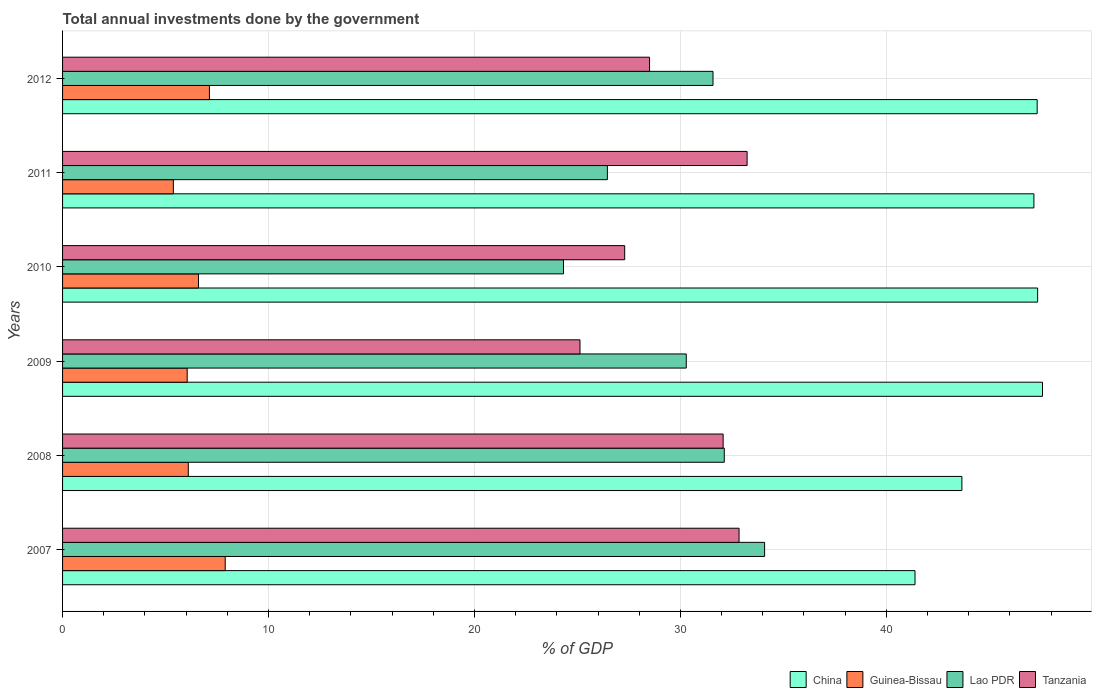How many groups of bars are there?
Provide a short and direct response. 6. Are the number of bars per tick equal to the number of legend labels?
Your answer should be compact. Yes. Are the number of bars on each tick of the Y-axis equal?
Your answer should be compact. Yes. What is the label of the 4th group of bars from the top?
Your answer should be very brief. 2009. What is the total annual investments done by the government in Lao PDR in 2009?
Give a very brief answer. 30.29. Across all years, what is the maximum total annual investments done by the government in Lao PDR?
Provide a short and direct response. 34.09. Across all years, what is the minimum total annual investments done by the government in Lao PDR?
Ensure brevity in your answer.  24.32. In which year was the total annual investments done by the government in Tanzania maximum?
Your answer should be very brief. 2011. In which year was the total annual investments done by the government in Guinea-Bissau minimum?
Provide a succinct answer. 2011. What is the total total annual investments done by the government in China in the graph?
Give a very brief answer. 274.49. What is the difference between the total annual investments done by the government in Guinea-Bissau in 2007 and that in 2010?
Give a very brief answer. 1.3. What is the difference between the total annual investments done by the government in Tanzania in 2011 and the total annual investments done by the government in China in 2012?
Your response must be concise. -14.08. What is the average total annual investments done by the government in Lao PDR per year?
Give a very brief answer. 29.81. In the year 2011, what is the difference between the total annual investments done by the government in Tanzania and total annual investments done by the government in Lao PDR?
Your answer should be compact. 6.78. In how many years, is the total annual investments done by the government in China greater than 42 %?
Your response must be concise. 5. What is the ratio of the total annual investments done by the government in China in 2011 to that in 2012?
Your response must be concise. 1. Is the difference between the total annual investments done by the government in Tanzania in 2008 and 2011 greater than the difference between the total annual investments done by the government in Lao PDR in 2008 and 2011?
Offer a terse response. No. What is the difference between the highest and the second highest total annual investments done by the government in Lao PDR?
Your response must be concise. 1.96. What is the difference between the highest and the lowest total annual investments done by the government in Tanzania?
Offer a terse response. 8.12. What does the 3rd bar from the top in 2011 represents?
Give a very brief answer. Guinea-Bissau. What does the 2nd bar from the bottom in 2011 represents?
Provide a succinct answer. Guinea-Bissau. Is it the case that in every year, the sum of the total annual investments done by the government in Guinea-Bissau and total annual investments done by the government in Lao PDR is greater than the total annual investments done by the government in Tanzania?
Your answer should be very brief. No. How many years are there in the graph?
Your answer should be compact. 6. What is the difference between two consecutive major ticks on the X-axis?
Make the answer very short. 10. Are the values on the major ticks of X-axis written in scientific E-notation?
Ensure brevity in your answer.  No. Does the graph contain any zero values?
Provide a short and direct response. No. How many legend labels are there?
Your answer should be compact. 4. How are the legend labels stacked?
Your answer should be compact. Horizontal. What is the title of the graph?
Offer a very short reply. Total annual investments done by the government. What is the label or title of the X-axis?
Your response must be concise. % of GDP. What is the label or title of the Y-axis?
Your response must be concise. Years. What is the % of GDP in China in 2007?
Ensure brevity in your answer.  41.39. What is the % of GDP in Guinea-Bissau in 2007?
Offer a very short reply. 7.9. What is the % of GDP of Lao PDR in 2007?
Offer a terse response. 34.09. What is the % of GDP in Tanzania in 2007?
Provide a succinct answer. 32.85. What is the % of GDP in China in 2008?
Give a very brief answer. 43.67. What is the % of GDP in Guinea-Bissau in 2008?
Give a very brief answer. 6.11. What is the % of GDP in Lao PDR in 2008?
Your response must be concise. 32.13. What is the % of GDP of Tanzania in 2008?
Provide a short and direct response. 32.08. What is the % of GDP in China in 2009?
Provide a short and direct response. 47.58. What is the % of GDP in Guinea-Bissau in 2009?
Make the answer very short. 6.05. What is the % of GDP in Lao PDR in 2009?
Provide a succinct answer. 30.29. What is the % of GDP in Tanzania in 2009?
Make the answer very short. 25.13. What is the % of GDP in China in 2010?
Provide a short and direct response. 47.35. What is the % of GDP of Guinea-Bissau in 2010?
Offer a terse response. 6.6. What is the % of GDP in Lao PDR in 2010?
Offer a terse response. 24.32. What is the % of GDP in Tanzania in 2010?
Your answer should be very brief. 27.3. What is the % of GDP in China in 2011?
Give a very brief answer. 47.17. What is the % of GDP of Guinea-Bissau in 2011?
Provide a short and direct response. 5.38. What is the % of GDP in Lao PDR in 2011?
Make the answer very short. 26.46. What is the % of GDP in Tanzania in 2011?
Give a very brief answer. 33.24. What is the % of GDP of China in 2012?
Offer a very short reply. 47.32. What is the % of GDP of Guinea-Bissau in 2012?
Give a very brief answer. 7.13. What is the % of GDP in Lao PDR in 2012?
Offer a terse response. 31.58. What is the % of GDP of Tanzania in 2012?
Your response must be concise. 28.5. Across all years, what is the maximum % of GDP of China?
Provide a succinct answer. 47.58. Across all years, what is the maximum % of GDP in Guinea-Bissau?
Your answer should be compact. 7.9. Across all years, what is the maximum % of GDP of Lao PDR?
Ensure brevity in your answer.  34.09. Across all years, what is the maximum % of GDP in Tanzania?
Make the answer very short. 33.24. Across all years, what is the minimum % of GDP of China?
Ensure brevity in your answer.  41.39. Across all years, what is the minimum % of GDP of Guinea-Bissau?
Offer a very short reply. 5.38. Across all years, what is the minimum % of GDP in Lao PDR?
Offer a terse response. 24.32. Across all years, what is the minimum % of GDP of Tanzania?
Your response must be concise. 25.13. What is the total % of GDP of China in the graph?
Offer a terse response. 274.49. What is the total % of GDP in Guinea-Bissau in the graph?
Offer a very short reply. 39.17. What is the total % of GDP in Lao PDR in the graph?
Your response must be concise. 178.87. What is the total % of GDP in Tanzania in the graph?
Your response must be concise. 179.09. What is the difference between the % of GDP of China in 2007 and that in 2008?
Provide a short and direct response. -2.28. What is the difference between the % of GDP in Guinea-Bissau in 2007 and that in 2008?
Your answer should be compact. 1.79. What is the difference between the % of GDP in Lao PDR in 2007 and that in 2008?
Provide a succinct answer. 1.96. What is the difference between the % of GDP in Tanzania in 2007 and that in 2008?
Make the answer very short. 0.77. What is the difference between the % of GDP in China in 2007 and that in 2009?
Make the answer very short. -6.19. What is the difference between the % of GDP in Guinea-Bissau in 2007 and that in 2009?
Ensure brevity in your answer.  1.85. What is the difference between the % of GDP in Lao PDR in 2007 and that in 2009?
Provide a short and direct response. 3.8. What is the difference between the % of GDP in Tanzania in 2007 and that in 2009?
Provide a short and direct response. 7.72. What is the difference between the % of GDP of China in 2007 and that in 2010?
Keep it short and to the point. -5.95. What is the difference between the % of GDP in Guinea-Bissau in 2007 and that in 2010?
Give a very brief answer. 1.3. What is the difference between the % of GDP of Lao PDR in 2007 and that in 2010?
Make the answer very short. 9.77. What is the difference between the % of GDP in Tanzania in 2007 and that in 2010?
Offer a very short reply. 5.55. What is the difference between the % of GDP in China in 2007 and that in 2011?
Ensure brevity in your answer.  -5.77. What is the difference between the % of GDP of Guinea-Bissau in 2007 and that in 2011?
Offer a very short reply. 2.52. What is the difference between the % of GDP of Lao PDR in 2007 and that in 2011?
Ensure brevity in your answer.  7.63. What is the difference between the % of GDP of Tanzania in 2007 and that in 2011?
Provide a short and direct response. -0.39. What is the difference between the % of GDP in China in 2007 and that in 2012?
Your response must be concise. -5.93. What is the difference between the % of GDP in Guinea-Bissau in 2007 and that in 2012?
Offer a very short reply. 0.77. What is the difference between the % of GDP in Lao PDR in 2007 and that in 2012?
Your answer should be compact. 2.5. What is the difference between the % of GDP of Tanzania in 2007 and that in 2012?
Make the answer very short. 4.35. What is the difference between the % of GDP in China in 2008 and that in 2009?
Provide a short and direct response. -3.91. What is the difference between the % of GDP in Guinea-Bissau in 2008 and that in 2009?
Provide a short and direct response. 0.05. What is the difference between the % of GDP of Lao PDR in 2008 and that in 2009?
Make the answer very short. 1.85. What is the difference between the % of GDP in Tanzania in 2008 and that in 2009?
Your answer should be compact. 6.95. What is the difference between the % of GDP of China in 2008 and that in 2010?
Keep it short and to the point. -3.68. What is the difference between the % of GDP in Guinea-Bissau in 2008 and that in 2010?
Make the answer very short. -0.49. What is the difference between the % of GDP in Lao PDR in 2008 and that in 2010?
Offer a terse response. 7.81. What is the difference between the % of GDP of Tanzania in 2008 and that in 2010?
Your response must be concise. 4.78. What is the difference between the % of GDP of China in 2008 and that in 2011?
Provide a succinct answer. -3.5. What is the difference between the % of GDP of Guinea-Bissau in 2008 and that in 2011?
Offer a very short reply. 0.73. What is the difference between the % of GDP of Lao PDR in 2008 and that in 2011?
Ensure brevity in your answer.  5.68. What is the difference between the % of GDP in Tanzania in 2008 and that in 2011?
Your answer should be compact. -1.16. What is the difference between the % of GDP of China in 2008 and that in 2012?
Offer a terse response. -3.65. What is the difference between the % of GDP of Guinea-Bissau in 2008 and that in 2012?
Provide a succinct answer. -1.02. What is the difference between the % of GDP in Lao PDR in 2008 and that in 2012?
Make the answer very short. 0.55. What is the difference between the % of GDP in Tanzania in 2008 and that in 2012?
Offer a terse response. 3.57. What is the difference between the % of GDP in China in 2009 and that in 2010?
Your answer should be compact. 0.24. What is the difference between the % of GDP in Guinea-Bissau in 2009 and that in 2010?
Offer a terse response. -0.55. What is the difference between the % of GDP of Lao PDR in 2009 and that in 2010?
Provide a succinct answer. 5.96. What is the difference between the % of GDP of Tanzania in 2009 and that in 2010?
Offer a terse response. -2.17. What is the difference between the % of GDP in China in 2009 and that in 2011?
Your response must be concise. 0.42. What is the difference between the % of GDP of Guinea-Bissau in 2009 and that in 2011?
Make the answer very short. 0.67. What is the difference between the % of GDP in Lao PDR in 2009 and that in 2011?
Offer a very short reply. 3.83. What is the difference between the % of GDP of Tanzania in 2009 and that in 2011?
Provide a short and direct response. -8.12. What is the difference between the % of GDP in China in 2009 and that in 2012?
Make the answer very short. 0.26. What is the difference between the % of GDP in Guinea-Bissau in 2009 and that in 2012?
Ensure brevity in your answer.  -1.08. What is the difference between the % of GDP in Lao PDR in 2009 and that in 2012?
Your answer should be very brief. -1.3. What is the difference between the % of GDP in Tanzania in 2009 and that in 2012?
Make the answer very short. -3.38. What is the difference between the % of GDP of China in 2010 and that in 2011?
Ensure brevity in your answer.  0.18. What is the difference between the % of GDP in Guinea-Bissau in 2010 and that in 2011?
Provide a short and direct response. 1.22. What is the difference between the % of GDP of Lao PDR in 2010 and that in 2011?
Your response must be concise. -2.13. What is the difference between the % of GDP of Tanzania in 2010 and that in 2011?
Provide a short and direct response. -5.94. What is the difference between the % of GDP of China in 2010 and that in 2012?
Your response must be concise. 0.02. What is the difference between the % of GDP of Guinea-Bissau in 2010 and that in 2012?
Ensure brevity in your answer.  -0.53. What is the difference between the % of GDP of Lao PDR in 2010 and that in 2012?
Provide a short and direct response. -7.26. What is the difference between the % of GDP of Tanzania in 2010 and that in 2012?
Your response must be concise. -1.21. What is the difference between the % of GDP in China in 2011 and that in 2012?
Your response must be concise. -0.16. What is the difference between the % of GDP in Guinea-Bissau in 2011 and that in 2012?
Give a very brief answer. -1.75. What is the difference between the % of GDP in Lao PDR in 2011 and that in 2012?
Provide a succinct answer. -5.13. What is the difference between the % of GDP in Tanzania in 2011 and that in 2012?
Offer a terse response. 4.74. What is the difference between the % of GDP in China in 2007 and the % of GDP in Guinea-Bissau in 2008?
Make the answer very short. 35.29. What is the difference between the % of GDP in China in 2007 and the % of GDP in Lao PDR in 2008?
Keep it short and to the point. 9.26. What is the difference between the % of GDP of China in 2007 and the % of GDP of Tanzania in 2008?
Give a very brief answer. 9.32. What is the difference between the % of GDP in Guinea-Bissau in 2007 and the % of GDP in Lao PDR in 2008?
Ensure brevity in your answer.  -24.23. What is the difference between the % of GDP in Guinea-Bissau in 2007 and the % of GDP in Tanzania in 2008?
Ensure brevity in your answer.  -24.18. What is the difference between the % of GDP in Lao PDR in 2007 and the % of GDP in Tanzania in 2008?
Your answer should be compact. 2.01. What is the difference between the % of GDP of China in 2007 and the % of GDP of Guinea-Bissau in 2009?
Ensure brevity in your answer.  35.34. What is the difference between the % of GDP of China in 2007 and the % of GDP of Lao PDR in 2009?
Provide a succinct answer. 11.11. What is the difference between the % of GDP in China in 2007 and the % of GDP in Tanzania in 2009?
Ensure brevity in your answer.  16.27. What is the difference between the % of GDP of Guinea-Bissau in 2007 and the % of GDP of Lao PDR in 2009?
Ensure brevity in your answer.  -22.39. What is the difference between the % of GDP of Guinea-Bissau in 2007 and the % of GDP of Tanzania in 2009?
Provide a short and direct response. -17.23. What is the difference between the % of GDP in Lao PDR in 2007 and the % of GDP in Tanzania in 2009?
Give a very brief answer. 8.96. What is the difference between the % of GDP in China in 2007 and the % of GDP in Guinea-Bissau in 2010?
Give a very brief answer. 34.79. What is the difference between the % of GDP in China in 2007 and the % of GDP in Lao PDR in 2010?
Keep it short and to the point. 17.07. What is the difference between the % of GDP in China in 2007 and the % of GDP in Tanzania in 2010?
Your answer should be compact. 14.1. What is the difference between the % of GDP of Guinea-Bissau in 2007 and the % of GDP of Lao PDR in 2010?
Your answer should be very brief. -16.43. What is the difference between the % of GDP of Guinea-Bissau in 2007 and the % of GDP of Tanzania in 2010?
Give a very brief answer. -19.4. What is the difference between the % of GDP of Lao PDR in 2007 and the % of GDP of Tanzania in 2010?
Give a very brief answer. 6.79. What is the difference between the % of GDP in China in 2007 and the % of GDP in Guinea-Bissau in 2011?
Your answer should be very brief. 36.01. What is the difference between the % of GDP in China in 2007 and the % of GDP in Lao PDR in 2011?
Your answer should be compact. 14.94. What is the difference between the % of GDP in China in 2007 and the % of GDP in Tanzania in 2011?
Your answer should be compact. 8.15. What is the difference between the % of GDP in Guinea-Bissau in 2007 and the % of GDP in Lao PDR in 2011?
Ensure brevity in your answer.  -18.56. What is the difference between the % of GDP in Guinea-Bissau in 2007 and the % of GDP in Tanzania in 2011?
Provide a succinct answer. -25.34. What is the difference between the % of GDP of Lao PDR in 2007 and the % of GDP of Tanzania in 2011?
Offer a very short reply. 0.85. What is the difference between the % of GDP in China in 2007 and the % of GDP in Guinea-Bissau in 2012?
Provide a short and direct response. 34.26. What is the difference between the % of GDP of China in 2007 and the % of GDP of Lao PDR in 2012?
Your answer should be compact. 9.81. What is the difference between the % of GDP in China in 2007 and the % of GDP in Tanzania in 2012?
Offer a very short reply. 12.89. What is the difference between the % of GDP in Guinea-Bissau in 2007 and the % of GDP in Lao PDR in 2012?
Keep it short and to the point. -23.69. What is the difference between the % of GDP in Guinea-Bissau in 2007 and the % of GDP in Tanzania in 2012?
Ensure brevity in your answer.  -20.6. What is the difference between the % of GDP in Lao PDR in 2007 and the % of GDP in Tanzania in 2012?
Provide a succinct answer. 5.59. What is the difference between the % of GDP in China in 2008 and the % of GDP in Guinea-Bissau in 2009?
Your answer should be compact. 37.62. What is the difference between the % of GDP of China in 2008 and the % of GDP of Lao PDR in 2009?
Make the answer very short. 13.38. What is the difference between the % of GDP of China in 2008 and the % of GDP of Tanzania in 2009?
Keep it short and to the point. 18.54. What is the difference between the % of GDP of Guinea-Bissau in 2008 and the % of GDP of Lao PDR in 2009?
Your answer should be very brief. -24.18. What is the difference between the % of GDP of Guinea-Bissau in 2008 and the % of GDP of Tanzania in 2009?
Your answer should be compact. -19.02. What is the difference between the % of GDP in Lao PDR in 2008 and the % of GDP in Tanzania in 2009?
Make the answer very short. 7.01. What is the difference between the % of GDP of China in 2008 and the % of GDP of Guinea-Bissau in 2010?
Make the answer very short. 37.07. What is the difference between the % of GDP of China in 2008 and the % of GDP of Lao PDR in 2010?
Give a very brief answer. 19.35. What is the difference between the % of GDP of China in 2008 and the % of GDP of Tanzania in 2010?
Offer a terse response. 16.37. What is the difference between the % of GDP of Guinea-Bissau in 2008 and the % of GDP of Lao PDR in 2010?
Provide a succinct answer. -18.22. What is the difference between the % of GDP in Guinea-Bissau in 2008 and the % of GDP in Tanzania in 2010?
Give a very brief answer. -21.19. What is the difference between the % of GDP of Lao PDR in 2008 and the % of GDP of Tanzania in 2010?
Your answer should be compact. 4.84. What is the difference between the % of GDP of China in 2008 and the % of GDP of Guinea-Bissau in 2011?
Give a very brief answer. 38.29. What is the difference between the % of GDP in China in 2008 and the % of GDP in Lao PDR in 2011?
Your response must be concise. 17.21. What is the difference between the % of GDP of China in 2008 and the % of GDP of Tanzania in 2011?
Your answer should be compact. 10.43. What is the difference between the % of GDP in Guinea-Bissau in 2008 and the % of GDP in Lao PDR in 2011?
Your answer should be very brief. -20.35. What is the difference between the % of GDP in Guinea-Bissau in 2008 and the % of GDP in Tanzania in 2011?
Provide a succinct answer. -27.13. What is the difference between the % of GDP of Lao PDR in 2008 and the % of GDP of Tanzania in 2011?
Your response must be concise. -1.11. What is the difference between the % of GDP of China in 2008 and the % of GDP of Guinea-Bissau in 2012?
Provide a short and direct response. 36.54. What is the difference between the % of GDP of China in 2008 and the % of GDP of Lao PDR in 2012?
Your answer should be very brief. 12.09. What is the difference between the % of GDP in China in 2008 and the % of GDP in Tanzania in 2012?
Your response must be concise. 15.17. What is the difference between the % of GDP of Guinea-Bissau in 2008 and the % of GDP of Lao PDR in 2012?
Make the answer very short. -25.48. What is the difference between the % of GDP in Guinea-Bissau in 2008 and the % of GDP in Tanzania in 2012?
Your answer should be very brief. -22.4. What is the difference between the % of GDP of Lao PDR in 2008 and the % of GDP of Tanzania in 2012?
Provide a succinct answer. 3.63. What is the difference between the % of GDP in China in 2009 and the % of GDP in Guinea-Bissau in 2010?
Offer a terse response. 40.98. What is the difference between the % of GDP in China in 2009 and the % of GDP in Lao PDR in 2010?
Your response must be concise. 23.26. What is the difference between the % of GDP in China in 2009 and the % of GDP in Tanzania in 2010?
Offer a terse response. 20.29. What is the difference between the % of GDP in Guinea-Bissau in 2009 and the % of GDP in Lao PDR in 2010?
Provide a short and direct response. -18.27. What is the difference between the % of GDP in Guinea-Bissau in 2009 and the % of GDP in Tanzania in 2010?
Offer a terse response. -21.24. What is the difference between the % of GDP in Lao PDR in 2009 and the % of GDP in Tanzania in 2010?
Your answer should be very brief. 2.99. What is the difference between the % of GDP of China in 2009 and the % of GDP of Guinea-Bissau in 2011?
Provide a short and direct response. 42.2. What is the difference between the % of GDP in China in 2009 and the % of GDP in Lao PDR in 2011?
Offer a very short reply. 21.13. What is the difference between the % of GDP in China in 2009 and the % of GDP in Tanzania in 2011?
Give a very brief answer. 14.34. What is the difference between the % of GDP of Guinea-Bissau in 2009 and the % of GDP of Lao PDR in 2011?
Offer a very short reply. -20.4. What is the difference between the % of GDP in Guinea-Bissau in 2009 and the % of GDP in Tanzania in 2011?
Keep it short and to the point. -27.19. What is the difference between the % of GDP of Lao PDR in 2009 and the % of GDP of Tanzania in 2011?
Keep it short and to the point. -2.95. What is the difference between the % of GDP of China in 2009 and the % of GDP of Guinea-Bissau in 2012?
Give a very brief answer. 40.45. What is the difference between the % of GDP in China in 2009 and the % of GDP in Lao PDR in 2012?
Offer a terse response. 16. What is the difference between the % of GDP in China in 2009 and the % of GDP in Tanzania in 2012?
Provide a succinct answer. 19.08. What is the difference between the % of GDP in Guinea-Bissau in 2009 and the % of GDP in Lao PDR in 2012?
Offer a terse response. -25.53. What is the difference between the % of GDP of Guinea-Bissau in 2009 and the % of GDP of Tanzania in 2012?
Provide a succinct answer. -22.45. What is the difference between the % of GDP in Lao PDR in 2009 and the % of GDP in Tanzania in 2012?
Give a very brief answer. 1.78. What is the difference between the % of GDP of China in 2010 and the % of GDP of Guinea-Bissau in 2011?
Offer a terse response. 41.97. What is the difference between the % of GDP of China in 2010 and the % of GDP of Lao PDR in 2011?
Your answer should be compact. 20.89. What is the difference between the % of GDP in China in 2010 and the % of GDP in Tanzania in 2011?
Offer a very short reply. 14.11. What is the difference between the % of GDP of Guinea-Bissau in 2010 and the % of GDP of Lao PDR in 2011?
Offer a terse response. -19.86. What is the difference between the % of GDP in Guinea-Bissau in 2010 and the % of GDP in Tanzania in 2011?
Your answer should be very brief. -26.64. What is the difference between the % of GDP in Lao PDR in 2010 and the % of GDP in Tanzania in 2011?
Ensure brevity in your answer.  -8.92. What is the difference between the % of GDP of China in 2010 and the % of GDP of Guinea-Bissau in 2012?
Your answer should be very brief. 40.22. What is the difference between the % of GDP of China in 2010 and the % of GDP of Lao PDR in 2012?
Ensure brevity in your answer.  15.76. What is the difference between the % of GDP in China in 2010 and the % of GDP in Tanzania in 2012?
Offer a terse response. 18.84. What is the difference between the % of GDP of Guinea-Bissau in 2010 and the % of GDP of Lao PDR in 2012?
Your answer should be compact. -24.98. What is the difference between the % of GDP in Guinea-Bissau in 2010 and the % of GDP in Tanzania in 2012?
Your answer should be compact. -21.9. What is the difference between the % of GDP in Lao PDR in 2010 and the % of GDP in Tanzania in 2012?
Keep it short and to the point. -4.18. What is the difference between the % of GDP of China in 2011 and the % of GDP of Guinea-Bissau in 2012?
Keep it short and to the point. 40.04. What is the difference between the % of GDP of China in 2011 and the % of GDP of Lao PDR in 2012?
Give a very brief answer. 15.58. What is the difference between the % of GDP in China in 2011 and the % of GDP in Tanzania in 2012?
Provide a short and direct response. 18.66. What is the difference between the % of GDP in Guinea-Bissau in 2011 and the % of GDP in Lao PDR in 2012?
Ensure brevity in your answer.  -26.21. What is the difference between the % of GDP in Guinea-Bissau in 2011 and the % of GDP in Tanzania in 2012?
Your answer should be very brief. -23.12. What is the difference between the % of GDP of Lao PDR in 2011 and the % of GDP of Tanzania in 2012?
Give a very brief answer. -2.05. What is the average % of GDP of China per year?
Provide a succinct answer. 45.75. What is the average % of GDP in Guinea-Bissau per year?
Your response must be concise. 6.53. What is the average % of GDP of Lao PDR per year?
Your answer should be compact. 29.81. What is the average % of GDP of Tanzania per year?
Make the answer very short. 29.85. In the year 2007, what is the difference between the % of GDP of China and % of GDP of Guinea-Bissau?
Your answer should be compact. 33.5. In the year 2007, what is the difference between the % of GDP in China and % of GDP in Lao PDR?
Offer a very short reply. 7.3. In the year 2007, what is the difference between the % of GDP in China and % of GDP in Tanzania?
Provide a succinct answer. 8.54. In the year 2007, what is the difference between the % of GDP of Guinea-Bissau and % of GDP of Lao PDR?
Your response must be concise. -26.19. In the year 2007, what is the difference between the % of GDP in Guinea-Bissau and % of GDP in Tanzania?
Provide a succinct answer. -24.95. In the year 2007, what is the difference between the % of GDP of Lao PDR and % of GDP of Tanzania?
Offer a very short reply. 1.24. In the year 2008, what is the difference between the % of GDP in China and % of GDP in Guinea-Bissau?
Your answer should be very brief. 37.56. In the year 2008, what is the difference between the % of GDP of China and % of GDP of Lao PDR?
Make the answer very short. 11.54. In the year 2008, what is the difference between the % of GDP in China and % of GDP in Tanzania?
Provide a succinct answer. 11.59. In the year 2008, what is the difference between the % of GDP of Guinea-Bissau and % of GDP of Lao PDR?
Your answer should be very brief. -26.03. In the year 2008, what is the difference between the % of GDP in Guinea-Bissau and % of GDP in Tanzania?
Keep it short and to the point. -25.97. In the year 2008, what is the difference between the % of GDP of Lao PDR and % of GDP of Tanzania?
Keep it short and to the point. 0.06. In the year 2009, what is the difference between the % of GDP in China and % of GDP in Guinea-Bissau?
Make the answer very short. 41.53. In the year 2009, what is the difference between the % of GDP in China and % of GDP in Lao PDR?
Your answer should be very brief. 17.3. In the year 2009, what is the difference between the % of GDP of China and % of GDP of Tanzania?
Your answer should be compact. 22.46. In the year 2009, what is the difference between the % of GDP in Guinea-Bissau and % of GDP in Lao PDR?
Provide a succinct answer. -24.23. In the year 2009, what is the difference between the % of GDP of Guinea-Bissau and % of GDP of Tanzania?
Your answer should be compact. -19.07. In the year 2009, what is the difference between the % of GDP of Lao PDR and % of GDP of Tanzania?
Provide a short and direct response. 5.16. In the year 2010, what is the difference between the % of GDP of China and % of GDP of Guinea-Bissau?
Give a very brief answer. 40.75. In the year 2010, what is the difference between the % of GDP in China and % of GDP in Lao PDR?
Your response must be concise. 23.02. In the year 2010, what is the difference between the % of GDP in China and % of GDP in Tanzania?
Ensure brevity in your answer.  20.05. In the year 2010, what is the difference between the % of GDP in Guinea-Bissau and % of GDP in Lao PDR?
Offer a terse response. -17.72. In the year 2010, what is the difference between the % of GDP in Guinea-Bissau and % of GDP in Tanzania?
Provide a short and direct response. -20.7. In the year 2010, what is the difference between the % of GDP in Lao PDR and % of GDP in Tanzania?
Give a very brief answer. -2.97. In the year 2011, what is the difference between the % of GDP in China and % of GDP in Guinea-Bissau?
Offer a terse response. 41.79. In the year 2011, what is the difference between the % of GDP of China and % of GDP of Lao PDR?
Your response must be concise. 20.71. In the year 2011, what is the difference between the % of GDP in China and % of GDP in Tanzania?
Keep it short and to the point. 13.93. In the year 2011, what is the difference between the % of GDP in Guinea-Bissau and % of GDP in Lao PDR?
Your answer should be very brief. -21.08. In the year 2011, what is the difference between the % of GDP in Guinea-Bissau and % of GDP in Tanzania?
Provide a succinct answer. -27.86. In the year 2011, what is the difference between the % of GDP in Lao PDR and % of GDP in Tanzania?
Offer a very short reply. -6.78. In the year 2012, what is the difference between the % of GDP of China and % of GDP of Guinea-Bissau?
Give a very brief answer. 40.19. In the year 2012, what is the difference between the % of GDP of China and % of GDP of Lao PDR?
Your response must be concise. 15.74. In the year 2012, what is the difference between the % of GDP of China and % of GDP of Tanzania?
Make the answer very short. 18.82. In the year 2012, what is the difference between the % of GDP of Guinea-Bissau and % of GDP of Lao PDR?
Your answer should be very brief. -24.45. In the year 2012, what is the difference between the % of GDP in Guinea-Bissau and % of GDP in Tanzania?
Offer a very short reply. -21.37. In the year 2012, what is the difference between the % of GDP in Lao PDR and % of GDP in Tanzania?
Your answer should be compact. 3.08. What is the ratio of the % of GDP of China in 2007 to that in 2008?
Make the answer very short. 0.95. What is the ratio of the % of GDP of Guinea-Bissau in 2007 to that in 2008?
Your answer should be very brief. 1.29. What is the ratio of the % of GDP of Lao PDR in 2007 to that in 2008?
Give a very brief answer. 1.06. What is the ratio of the % of GDP of Tanzania in 2007 to that in 2008?
Your answer should be very brief. 1.02. What is the ratio of the % of GDP of China in 2007 to that in 2009?
Your response must be concise. 0.87. What is the ratio of the % of GDP in Guinea-Bissau in 2007 to that in 2009?
Your answer should be compact. 1.31. What is the ratio of the % of GDP in Lao PDR in 2007 to that in 2009?
Offer a terse response. 1.13. What is the ratio of the % of GDP of Tanzania in 2007 to that in 2009?
Give a very brief answer. 1.31. What is the ratio of the % of GDP in China in 2007 to that in 2010?
Your answer should be very brief. 0.87. What is the ratio of the % of GDP in Guinea-Bissau in 2007 to that in 2010?
Keep it short and to the point. 1.2. What is the ratio of the % of GDP in Lao PDR in 2007 to that in 2010?
Provide a short and direct response. 1.4. What is the ratio of the % of GDP in Tanzania in 2007 to that in 2010?
Give a very brief answer. 1.2. What is the ratio of the % of GDP of China in 2007 to that in 2011?
Make the answer very short. 0.88. What is the ratio of the % of GDP of Guinea-Bissau in 2007 to that in 2011?
Your answer should be very brief. 1.47. What is the ratio of the % of GDP of Lao PDR in 2007 to that in 2011?
Your response must be concise. 1.29. What is the ratio of the % of GDP of Tanzania in 2007 to that in 2011?
Offer a terse response. 0.99. What is the ratio of the % of GDP of China in 2007 to that in 2012?
Give a very brief answer. 0.87. What is the ratio of the % of GDP in Guinea-Bissau in 2007 to that in 2012?
Offer a terse response. 1.11. What is the ratio of the % of GDP in Lao PDR in 2007 to that in 2012?
Offer a very short reply. 1.08. What is the ratio of the % of GDP of Tanzania in 2007 to that in 2012?
Your answer should be compact. 1.15. What is the ratio of the % of GDP of China in 2008 to that in 2009?
Give a very brief answer. 0.92. What is the ratio of the % of GDP in Guinea-Bissau in 2008 to that in 2009?
Offer a terse response. 1.01. What is the ratio of the % of GDP of Lao PDR in 2008 to that in 2009?
Make the answer very short. 1.06. What is the ratio of the % of GDP in Tanzania in 2008 to that in 2009?
Provide a succinct answer. 1.28. What is the ratio of the % of GDP in China in 2008 to that in 2010?
Your answer should be very brief. 0.92. What is the ratio of the % of GDP in Guinea-Bissau in 2008 to that in 2010?
Your answer should be very brief. 0.93. What is the ratio of the % of GDP in Lao PDR in 2008 to that in 2010?
Offer a terse response. 1.32. What is the ratio of the % of GDP of Tanzania in 2008 to that in 2010?
Your answer should be compact. 1.18. What is the ratio of the % of GDP in China in 2008 to that in 2011?
Your answer should be very brief. 0.93. What is the ratio of the % of GDP in Guinea-Bissau in 2008 to that in 2011?
Offer a terse response. 1.14. What is the ratio of the % of GDP of Lao PDR in 2008 to that in 2011?
Offer a very short reply. 1.21. What is the ratio of the % of GDP in Tanzania in 2008 to that in 2011?
Offer a very short reply. 0.96. What is the ratio of the % of GDP of China in 2008 to that in 2012?
Your response must be concise. 0.92. What is the ratio of the % of GDP of Guinea-Bissau in 2008 to that in 2012?
Provide a succinct answer. 0.86. What is the ratio of the % of GDP in Lao PDR in 2008 to that in 2012?
Ensure brevity in your answer.  1.02. What is the ratio of the % of GDP in Tanzania in 2008 to that in 2012?
Provide a succinct answer. 1.13. What is the ratio of the % of GDP in Guinea-Bissau in 2009 to that in 2010?
Ensure brevity in your answer.  0.92. What is the ratio of the % of GDP in Lao PDR in 2009 to that in 2010?
Ensure brevity in your answer.  1.25. What is the ratio of the % of GDP of Tanzania in 2009 to that in 2010?
Make the answer very short. 0.92. What is the ratio of the % of GDP of China in 2009 to that in 2011?
Make the answer very short. 1.01. What is the ratio of the % of GDP of Lao PDR in 2009 to that in 2011?
Give a very brief answer. 1.14. What is the ratio of the % of GDP of Tanzania in 2009 to that in 2011?
Your response must be concise. 0.76. What is the ratio of the % of GDP of Guinea-Bissau in 2009 to that in 2012?
Offer a terse response. 0.85. What is the ratio of the % of GDP in Lao PDR in 2009 to that in 2012?
Your answer should be very brief. 0.96. What is the ratio of the % of GDP of Tanzania in 2009 to that in 2012?
Give a very brief answer. 0.88. What is the ratio of the % of GDP of China in 2010 to that in 2011?
Your answer should be very brief. 1. What is the ratio of the % of GDP in Guinea-Bissau in 2010 to that in 2011?
Make the answer very short. 1.23. What is the ratio of the % of GDP in Lao PDR in 2010 to that in 2011?
Offer a very short reply. 0.92. What is the ratio of the % of GDP of Tanzania in 2010 to that in 2011?
Make the answer very short. 0.82. What is the ratio of the % of GDP in Guinea-Bissau in 2010 to that in 2012?
Keep it short and to the point. 0.93. What is the ratio of the % of GDP of Lao PDR in 2010 to that in 2012?
Offer a terse response. 0.77. What is the ratio of the % of GDP of Tanzania in 2010 to that in 2012?
Offer a very short reply. 0.96. What is the ratio of the % of GDP in China in 2011 to that in 2012?
Ensure brevity in your answer.  1. What is the ratio of the % of GDP in Guinea-Bissau in 2011 to that in 2012?
Provide a short and direct response. 0.75. What is the ratio of the % of GDP of Lao PDR in 2011 to that in 2012?
Keep it short and to the point. 0.84. What is the ratio of the % of GDP in Tanzania in 2011 to that in 2012?
Offer a terse response. 1.17. What is the difference between the highest and the second highest % of GDP in China?
Your response must be concise. 0.24. What is the difference between the highest and the second highest % of GDP in Guinea-Bissau?
Keep it short and to the point. 0.77. What is the difference between the highest and the second highest % of GDP in Lao PDR?
Offer a very short reply. 1.96. What is the difference between the highest and the second highest % of GDP of Tanzania?
Your answer should be very brief. 0.39. What is the difference between the highest and the lowest % of GDP of China?
Provide a short and direct response. 6.19. What is the difference between the highest and the lowest % of GDP of Guinea-Bissau?
Keep it short and to the point. 2.52. What is the difference between the highest and the lowest % of GDP in Lao PDR?
Provide a succinct answer. 9.77. What is the difference between the highest and the lowest % of GDP of Tanzania?
Keep it short and to the point. 8.12. 